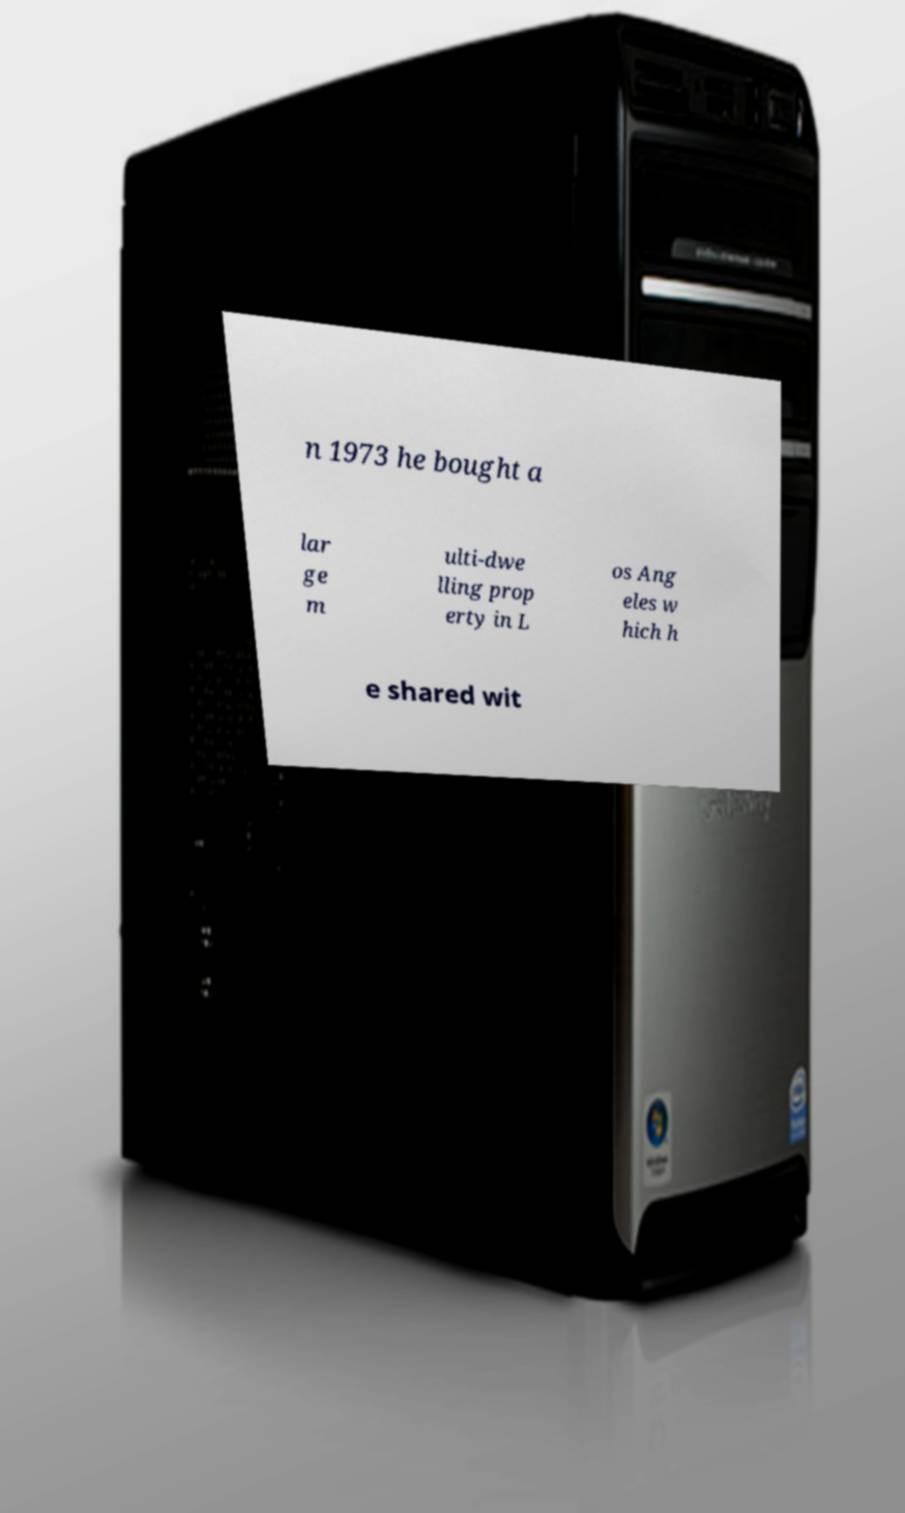Could you extract and type out the text from this image? n 1973 he bought a lar ge m ulti-dwe lling prop erty in L os Ang eles w hich h e shared wit 